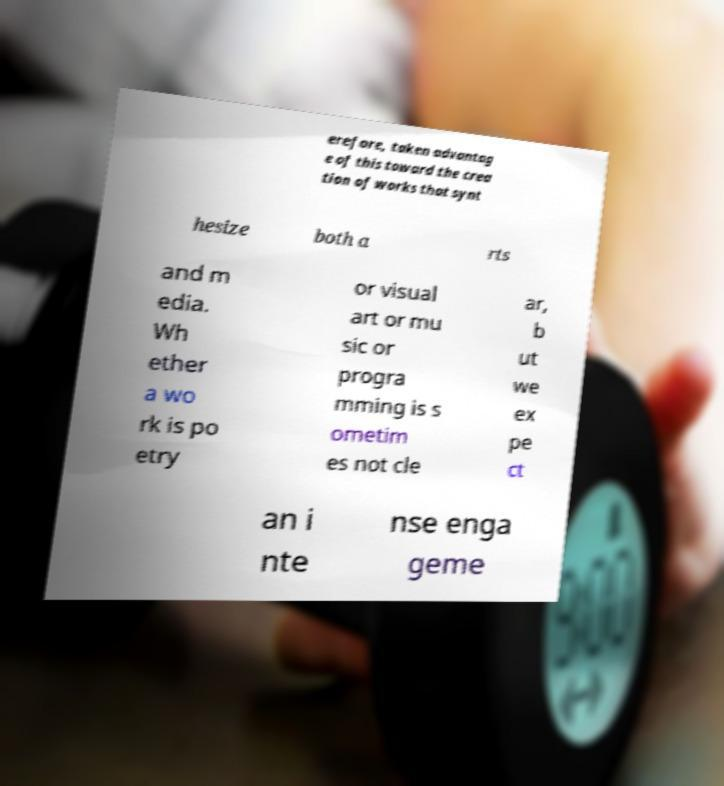I need the written content from this picture converted into text. Can you do that? erefore, taken advantag e of this toward the crea tion of works that synt hesize both a rts and m edia. Wh ether a wo rk is po etry or visual art or mu sic or progra mming is s ometim es not cle ar, b ut we ex pe ct an i nte nse enga geme 